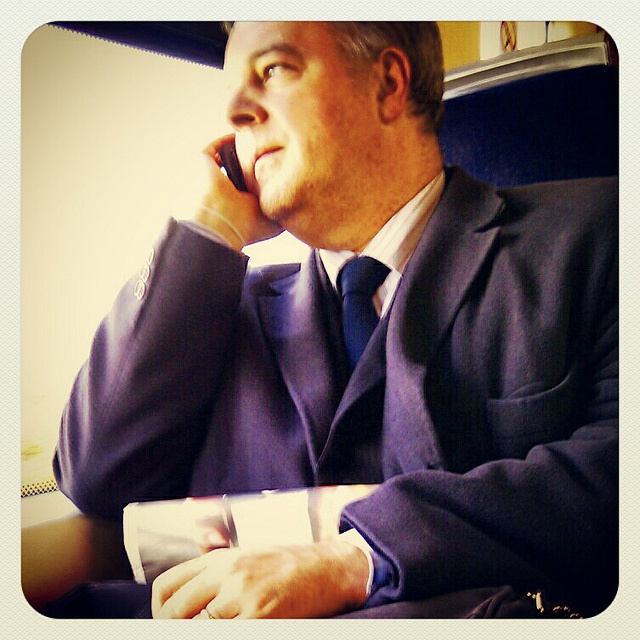Describe the objects in this image and their specific colors. I can see people in ivory, black, purple, and brown tones, tie in ivory, black, navy, purple, and gray tones, and cell phone in ivory, black, maroon, brown, and purple tones in this image. 